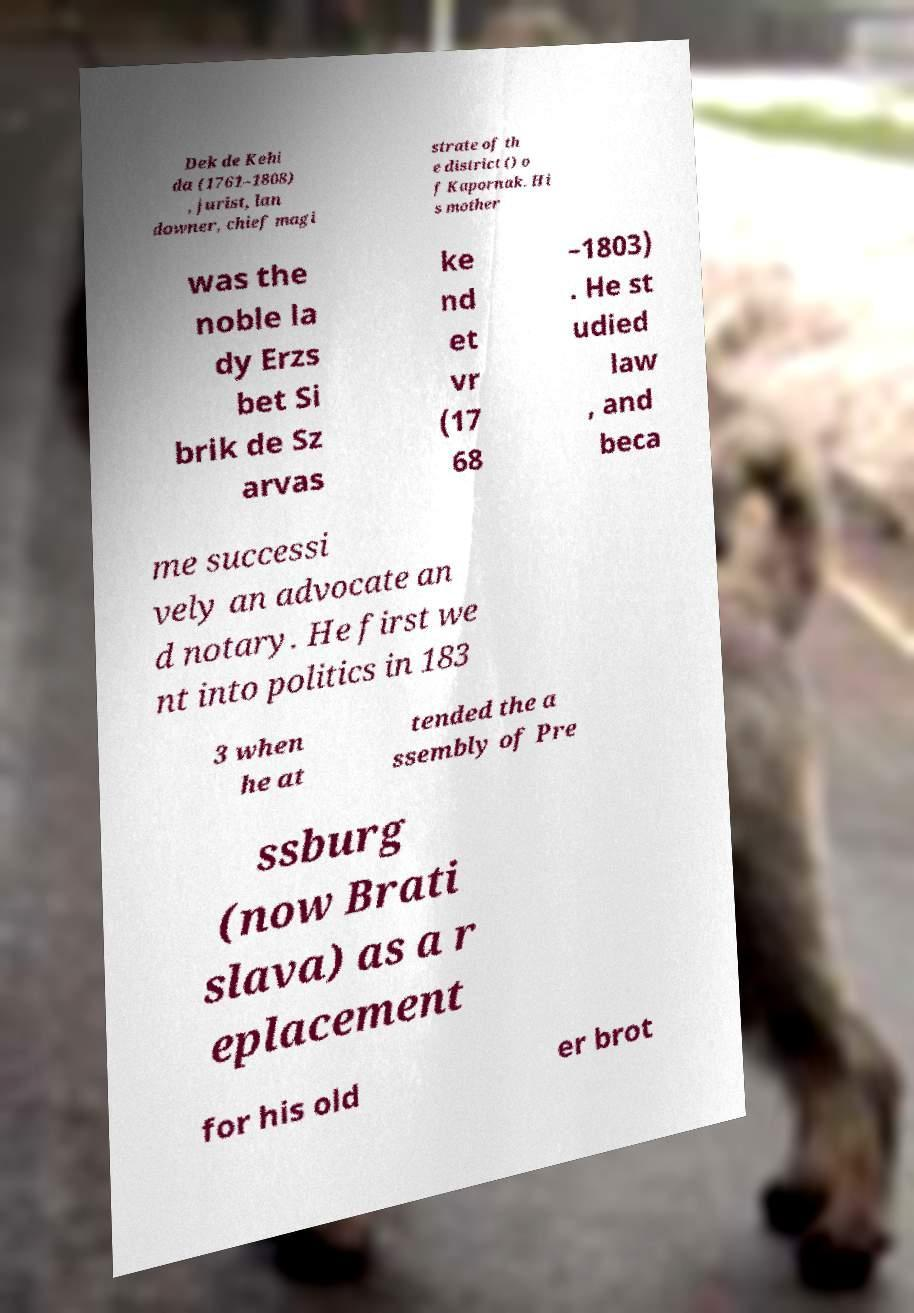Can you read and provide the text displayed in the image?This photo seems to have some interesting text. Can you extract and type it out for me? Dek de Kehi da (1761–1808) , jurist, lan downer, chief magi strate of th e district () o f Kapornak. Hi s mother was the noble la dy Erzs bet Si brik de Sz arvas ke nd et vr (17 68 –1803) . He st udied law , and beca me successi vely an advocate an d notary. He first we nt into politics in 183 3 when he at tended the a ssembly of Pre ssburg (now Brati slava) as a r eplacement for his old er brot 